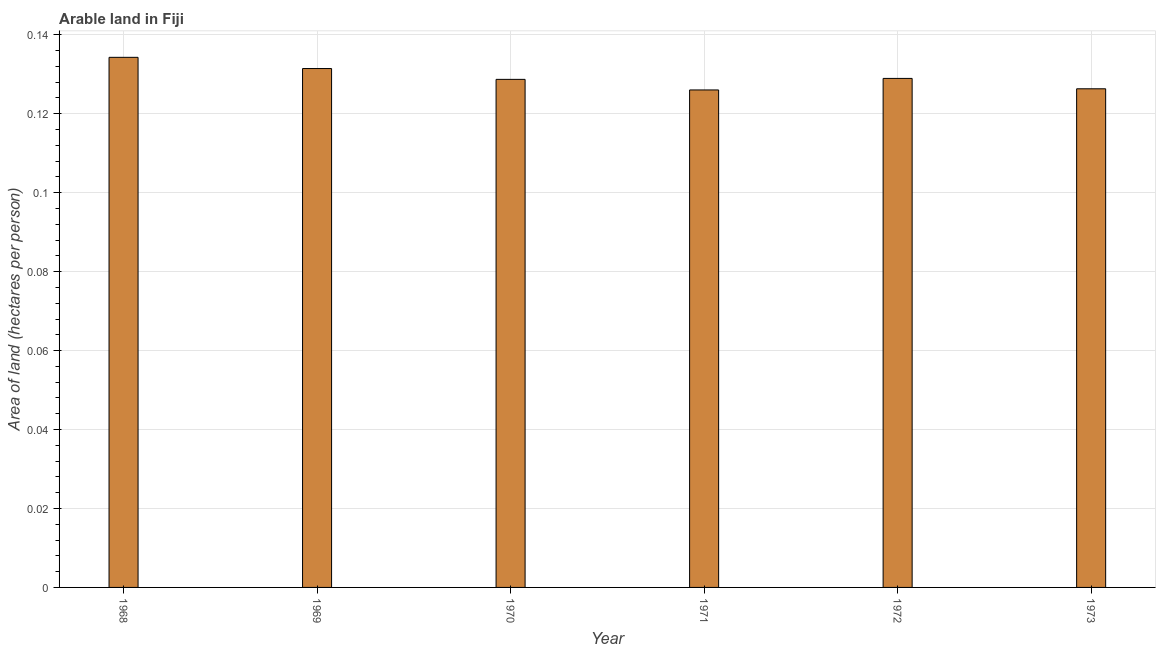What is the title of the graph?
Your answer should be compact. Arable land in Fiji. What is the label or title of the X-axis?
Your response must be concise. Year. What is the label or title of the Y-axis?
Your answer should be compact. Area of land (hectares per person). What is the area of arable land in 1970?
Ensure brevity in your answer.  0.13. Across all years, what is the maximum area of arable land?
Keep it short and to the point. 0.13. Across all years, what is the minimum area of arable land?
Offer a terse response. 0.13. In which year was the area of arable land maximum?
Your answer should be very brief. 1968. What is the sum of the area of arable land?
Ensure brevity in your answer.  0.78. What is the difference between the area of arable land in 1970 and 1972?
Your answer should be very brief. -0. What is the average area of arable land per year?
Provide a succinct answer. 0.13. What is the median area of arable land?
Your answer should be very brief. 0.13. What is the ratio of the area of arable land in 1968 to that in 1973?
Provide a short and direct response. 1.06. What is the difference between the highest and the second highest area of arable land?
Provide a short and direct response. 0. Is the sum of the area of arable land in 1968 and 1972 greater than the maximum area of arable land across all years?
Your response must be concise. Yes. How many bars are there?
Ensure brevity in your answer.  6. What is the difference between two consecutive major ticks on the Y-axis?
Offer a very short reply. 0.02. What is the Area of land (hectares per person) of 1968?
Provide a succinct answer. 0.13. What is the Area of land (hectares per person) of 1969?
Your answer should be compact. 0.13. What is the Area of land (hectares per person) of 1970?
Give a very brief answer. 0.13. What is the Area of land (hectares per person) of 1971?
Provide a short and direct response. 0.13. What is the Area of land (hectares per person) of 1972?
Your response must be concise. 0.13. What is the Area of land (hectares per person) of 1973?
Keep it short and to the point. 0.13. What is the difference between the Area of land (hectares per person) in 1968 and 1969?
Keep it short and to the point. 0. What is the difference between the Area of land (hectares per person) in 1968 and 1970?
Give a very brief answer. 0.01. What is the difference between the Area of land (hectares per person) in 1968 and 1971?
Provide a short and direct response. 0.01. What is the difference between the Area of land (hectares per person) in 1968 and 1972?
Your answer should be compact. 0.01. What is the difference between the Area of land (hectares per person) in 1968 and 1973?
Provide a succinct answer. 0.01. What is the difference between the Area of land (hectares per person) in 1969 and 1970?
Offer a terse response. 0. What is the difference between the Area of land (hectares per person) in 1969 and 1971?
Your answer should be very brief. 0.01. What is the difference between the Area of land (hectares per person) in 1969 and 1972?
Provide a short and direct response. 0. What is the difference between the Area of land (hectares per person) in 1969 and 1973?
Make the answer very short. 0.01. What is the difference between the Area of land (hectares per person) in 1970 and 1971?
Give a very brief answer. 0. What is the difference between the Area of land (hectares per person) in 1970 and 1972?
Your answer should be very brief. -0. What is the difference between the Area of land (hectares per person) in 1970 and 1973?
Provide a succinct answer. 0. What is the difference between the Area of land (hectares per person) in 1971 and 1972?
Provide a succinct answer. -0. What is the difference between the Area of land (hectares per person) in 1971 and 1973?
Offer a terse response. -0. What is the difference between the Area of land (hectares per person) in 1972 and 1973?
Give a very brief answer. 0. What is the ratio of the Area of land (hectares per person) in 1968 to that in 1970?
Provide a short and direct response. 1.04. What is the ratio of the Area of land (hectares per person) in 1968 to that in 1971?
Offer a very short reply. 1.07. What is the ratio of the Area of land (hectares per person) in 1968 to that in 1972?
Your response must be concise. 1.04. What is the ratio of the Area of land (hectares per person) in 1968 to that in 1973?
Your answer should be compact. 1.06. What is the ratio of the Area of land (hectares per person) in 1969 to that in 1970?
Make the answer very short. 1.02. What is the ratio of the Area of land (hectares per person) in 1969 to that in 1971?
Offer a very short reply. 1.04. What is the ratio of the Area of land (hectares per person) in 1969 to that in 1972?
Your answer should be very brief. 1.02. What is the ratio of the Area of land (hectares per person) in 1969 to that in 1973?
Provide a succinct answer. 1.04. What is the ratio of the Area of land (hectares per person) in 1970 to that in 1971?
Your response must be concise. 1.02. What is the ratio of the Area of land (hectares per person) in 1970 to that in 1973?
Give a very brief answer. 1.02. What is the ratio of the Area of land (hectares per person) in 1971 to that in 1972?
Offer a very short reply. 0.98. What is the ratio of the Area of land (hectares per person) in 1971 to that in 1973?
Your response must be concise. 1. What is the ratio of the Area of land (hectares per person) in 1972 to that in 1973?
Provide a short and direct response. 1.02. 